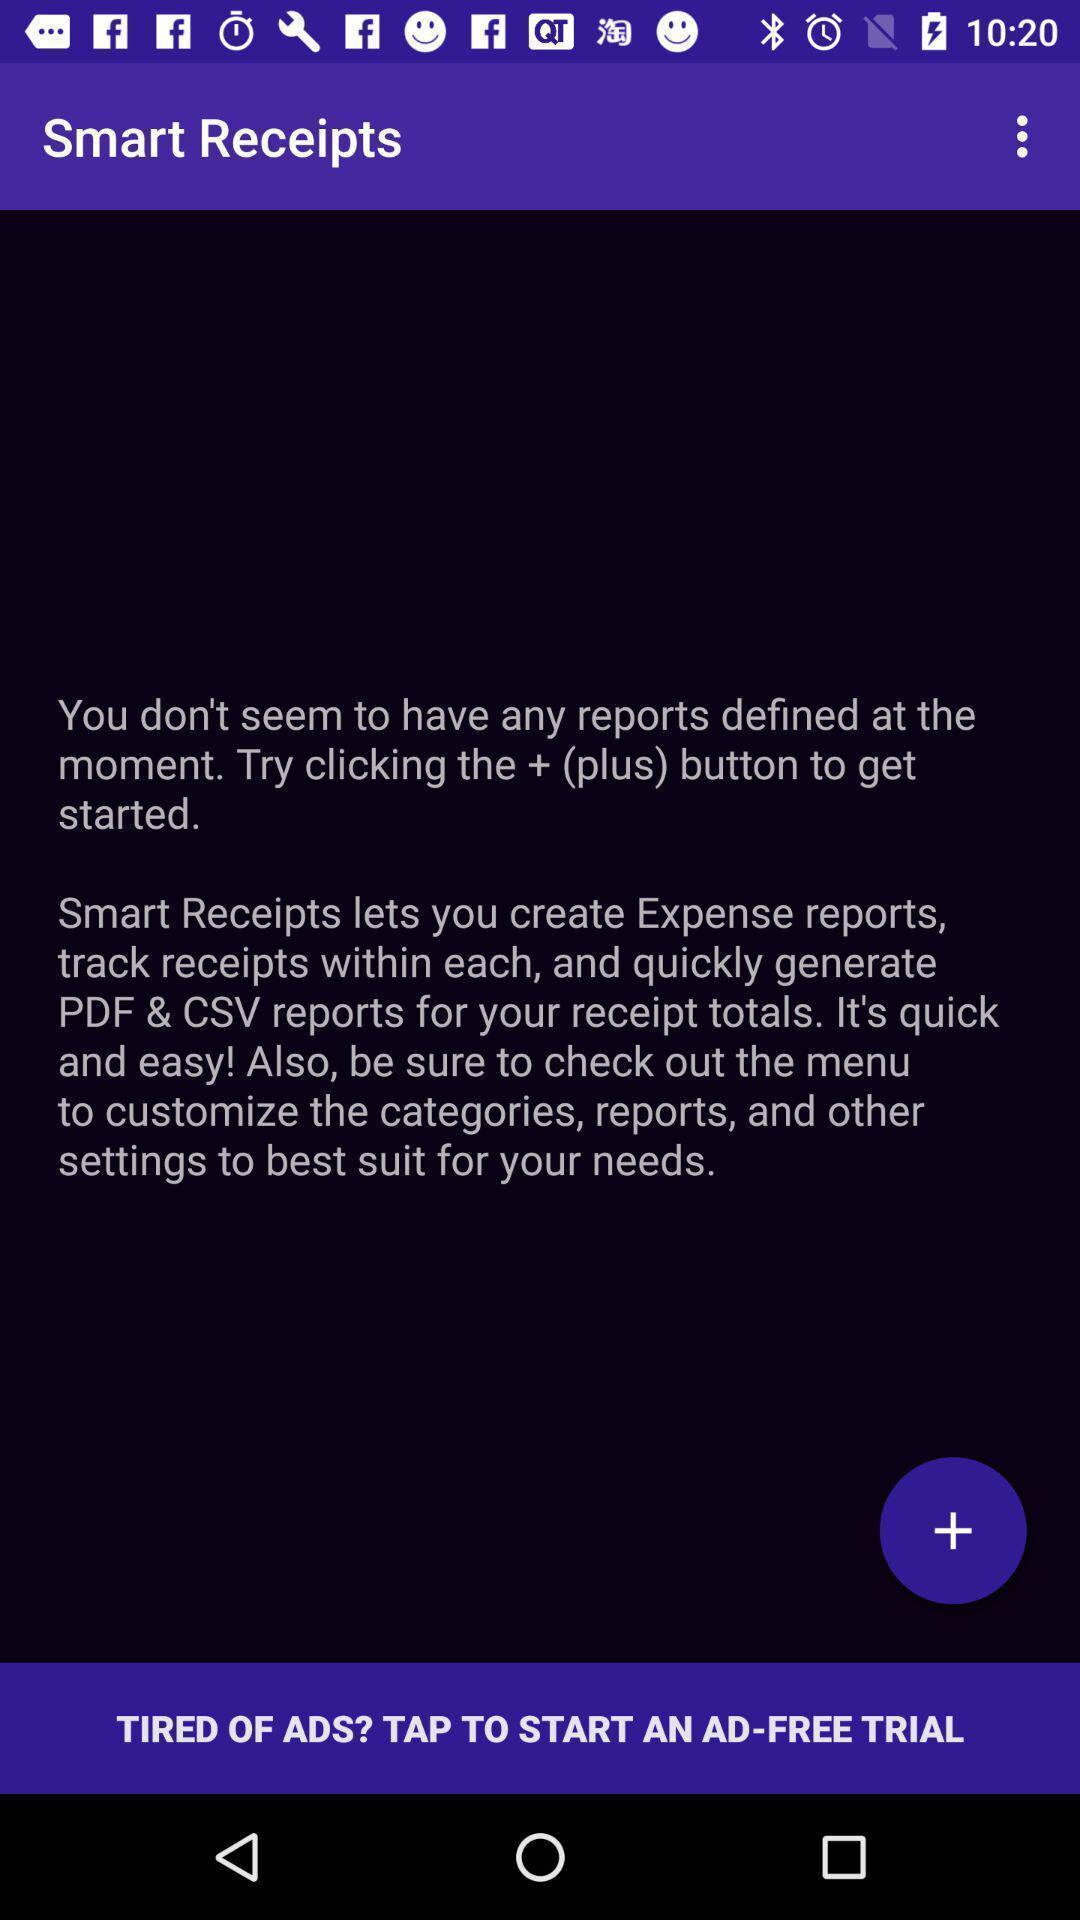Tell me what you see in this picture. Page showing information about receipts. 